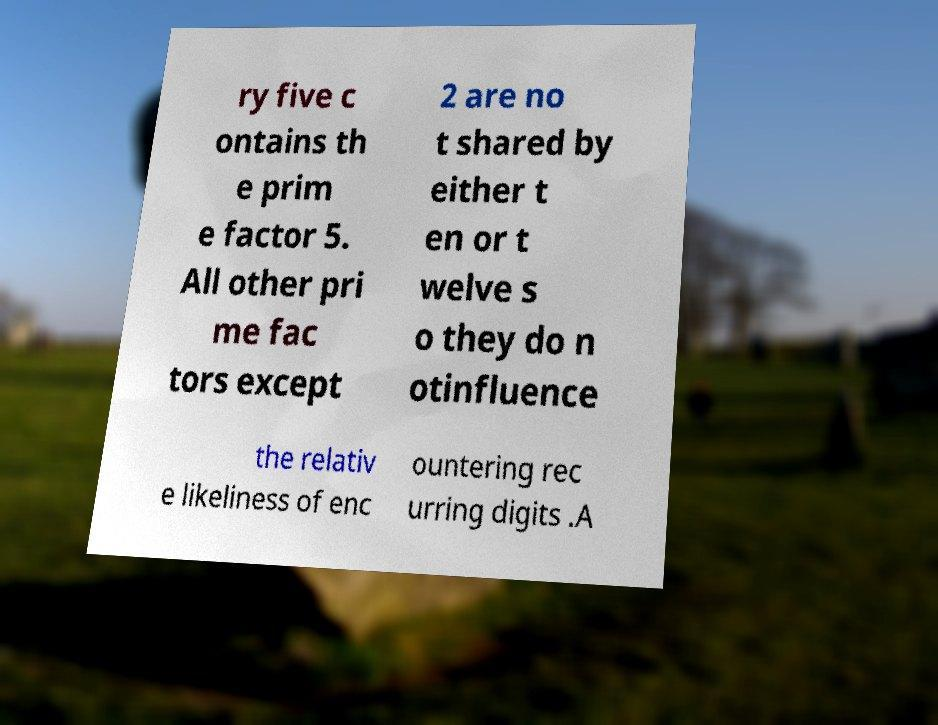Can you accurately transcribe the text from the provided image for me? ry five c ontains th e prim e factor 5. All other pri me fac tors except 2 are no t shared by either t en or t welve s o they do n otinfluence the relativ e likeliness of enc ountering rec urring digits .A 